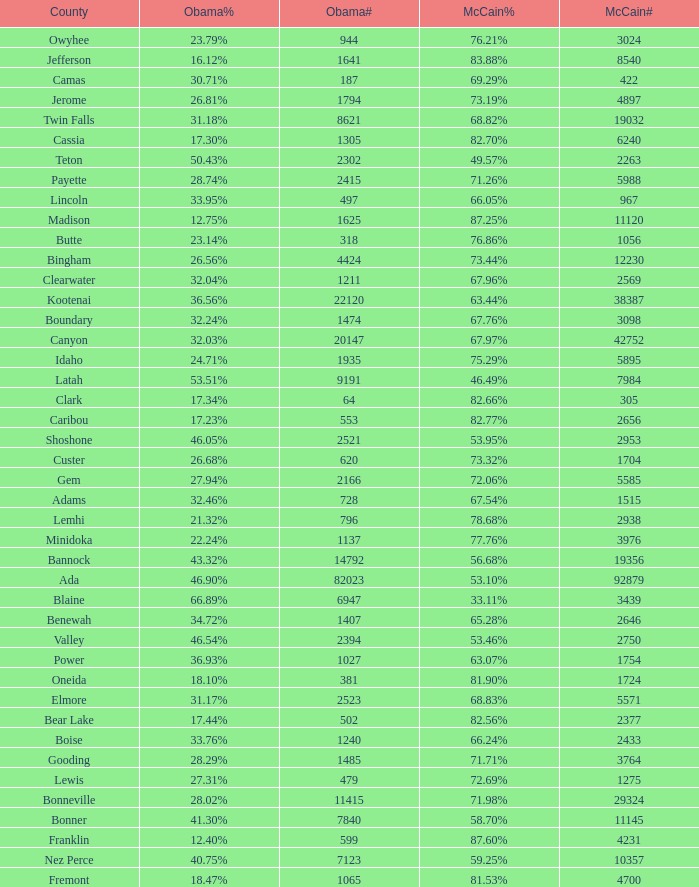What is the total number of McCain vote totals where Obama percentages was 17.34%? 1.0. 